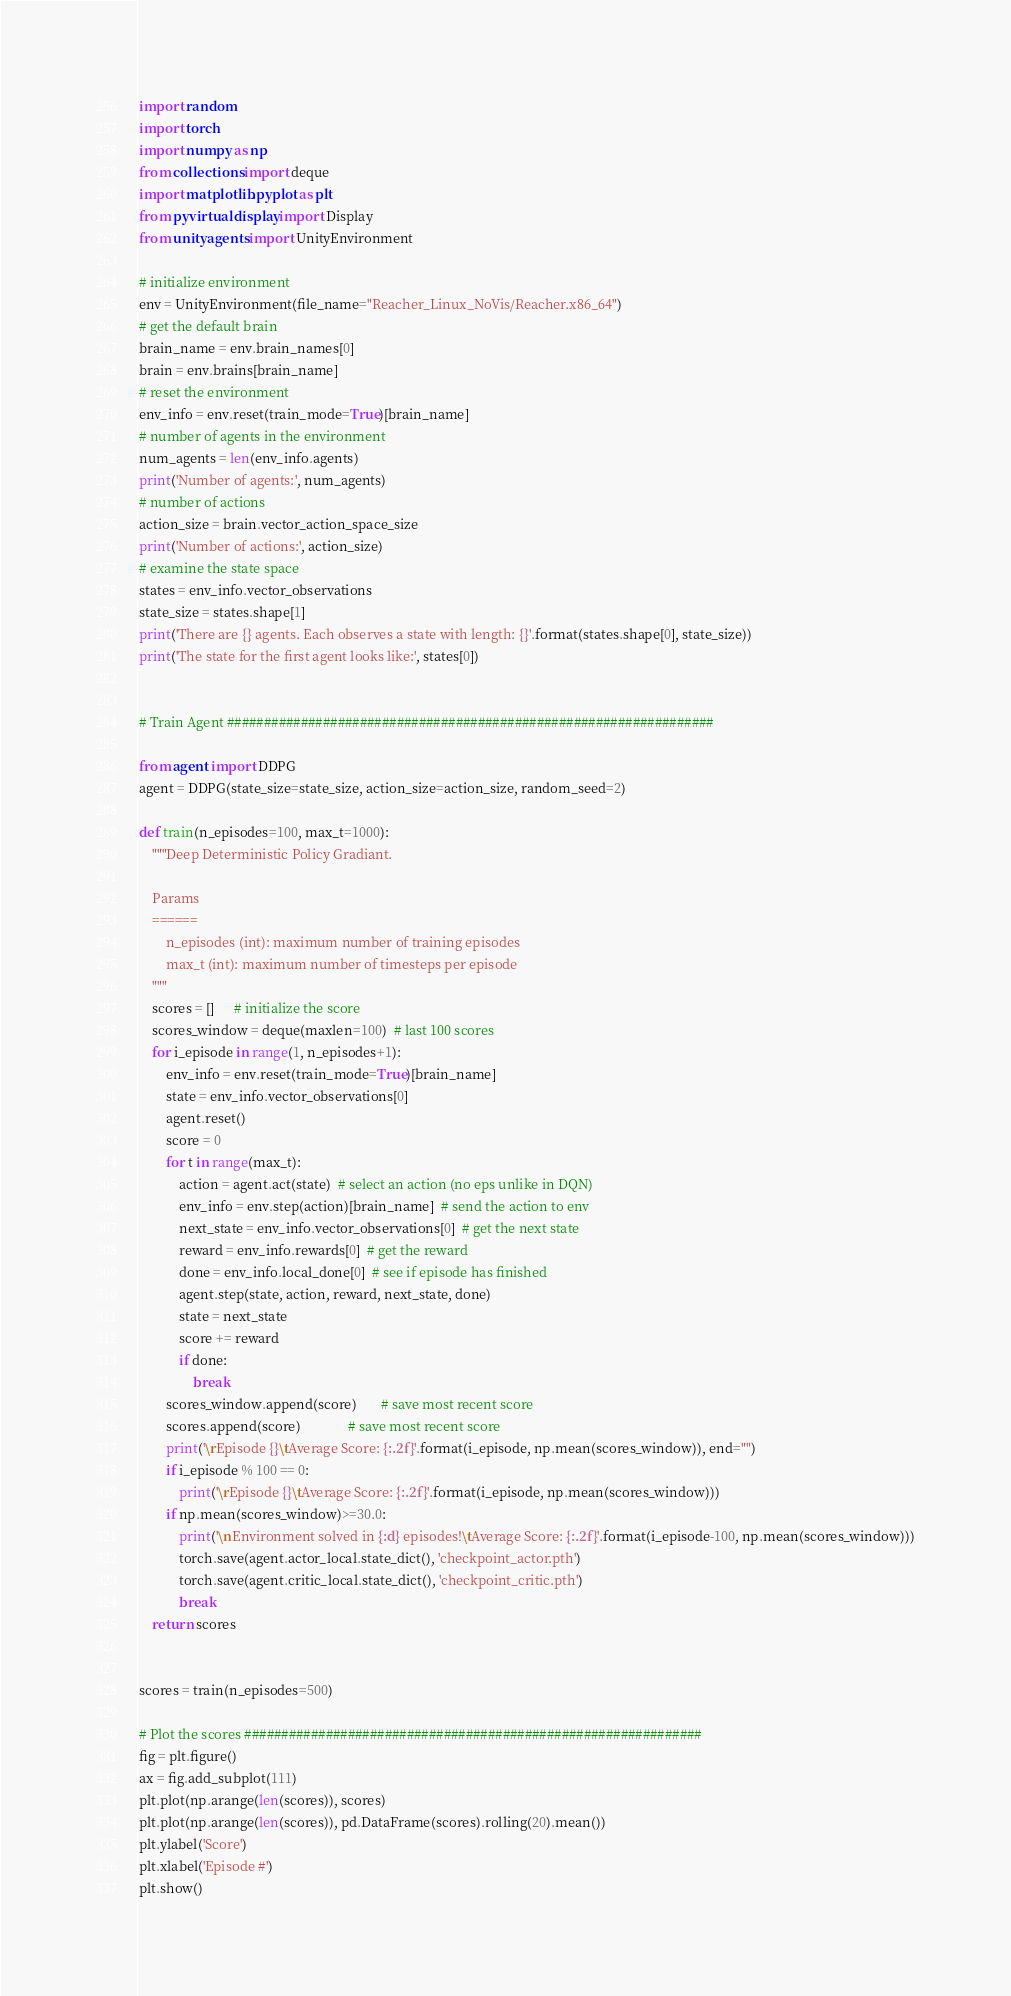<code> <loc_0><loc_0><loc_500><loc_500><_Python_>import random
import torch
import numpy as np
from collections import deque
import matplotlib.pyplot as plt
from pyvirtualdisplay import Display
from unityagents import UnityEnvironment

# initialize environment
env = UnityEnvironment(file_name="Reacher_Linux_NoVis/Reacher.x86_64")
# get the default brain
brain_name = env.brain_names[0]
brain = env.brains[brain_name]
# reset the environment
env_info = env.reset(train_mode=True)[brain_name]
# number of agents in the environment
num_agents = len(env_info.agents)
print('Number of agents:', num_agents)
# number of actions
action_size = brain.vector_action_space_size
print('Number of actions:', action_size)
# examine the state space
states = env_info.vector_observations
state_size = states.shape[1]
print('There are {} agents. Each observes a state with length: {}'.format(states.shape[0], state_size))
print('The state for the first agent looks like:', states[0])


# Train Agent ##################################################################

from agent import DDPG
agent = DDPG(state_size=state_size, action_size=action_size, random_seed=2)

def train(n_episodes=100, max_t=1000):
    """Deep Deterministic Policy Gradiant.

    Params
    ======
        n_episodes (int): maximum number of training episodes
        max_t (int): maximum number of timesteps per episode
    """
    scores = []      # initialize the score
    scores_window = deque(maxlen=100)  # last 100 scores
    for i_episode in range(1, n_episodes+1):
        env_info = env.reset(train_mode=True)[brain_name]
        state = env_info.vector_observations[0]
        agent.reset()
        score = 0
        for t in range(max_t):
            action = agent.act(state)  # select an action (no eps unlike in DQN)
            env_info = env.step(action)[brain_name]  # send the action to env
            next_state = env_info.vector_observations[0]  # get the next state
            reward = env_info.rewards[0]  # get the reward
            done = env_info.local_done[0]  # see if episode has finished
            agent.step(state, action, reward, next_state, done)
            state = next_state
            score += reward
            if done:
                break
        scores_window.append(score)       # save most recent score
        scores.append(score)              # save most recent score
        print('\rEpisode {}\tAverage Score: {:.2f}'.format(i_episode, np.mean(scores_window)), end="")
        if i_episode % 100 == 0:
            print('\rEpisode {}\tAverage Score: {:.2f}'.format(i_episode, np.mean(scores_window)))
        if np.mean(scores_window)>=30.0:
            print('\nEnvironment solved in {:d} episodes!\tAverage Score: {:.2f}'.format(i_episode-100, np.mean(scores_window)))
            torch.save(agent.actor_local.state_dict(), 'checkpoint_actor.pth')
            torch.save(agent.critic_local.state_dict(), 'checkpoint_critic.pth')
            break
    return scores


scores = train(n_episodes=500)

# Plot the scores ##############################################################
fig = plt.figure()
ax = fig.add_subplot(111)
plt.plot(np.arange(len(scores)), scores)
plt.plot(np.arange(len(scores)), pd.DataFrame(scores).rolling(20).mean())
plt.ylabel('Score')
plt.xlabel('Episode #')
plt.show()
</code> 